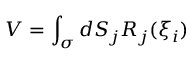<formula> <loc_0><loc_0><loc_500><loc_500>V = \int _ { \sigma } d S _ { j } R _ { j } ( \xi _ { i } )</formula> 